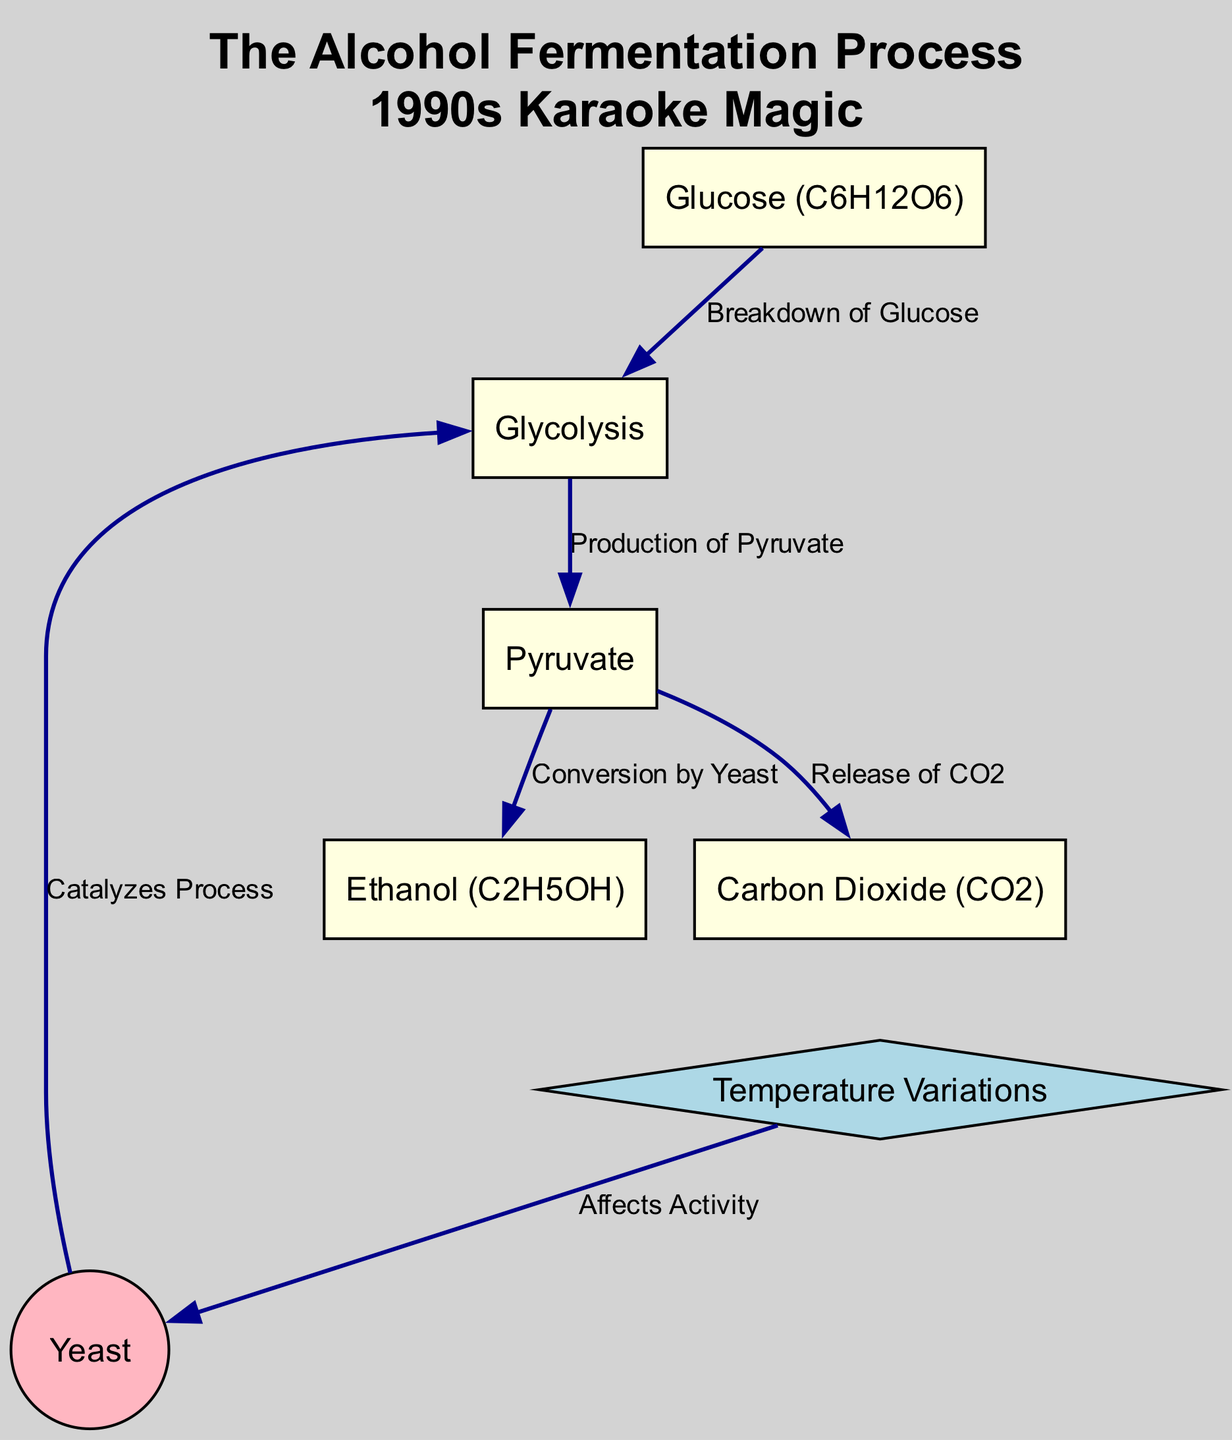What is the initial substance that undergoes fermentation? The diagram indicates that glucose is the starting compound for the fermentation process, as it is the first node before any transformations occur.
Answer: Glucose (C6H12O6) What gas is produced during the fermentation process? According to the diagram, one of the outputs of the fermentation process is carbon dioxide, which is listed directly as a product from pyruvate.
Answer: Carbon Dioxide (CO2) How many main processes are involved after glycolysis? By reviewing the edges connected to the pyruvate node, we see that it branches into two processes: conversion to ethanol and release of CO2, making it a total of two processes after glycolysis.
Answer: Two What role does yeast play in the fermentation process? The diagram shows that yeast is involved in catalyzing the conversion of pyruvate into ethanol, indicating its essential role in the conversion process.
Answer: Catalyzes Process How does temperature affect the alcohol fermentation process? The diagram states that temperature variations impact yeast, thereby affecting its activity, which is crucial for the fermentation efficiency and byproducts.
Answer: Affects Activity What is the output of the conversion of pyruvate by yeast? The diagram specifies that the conversion of pyruvate by yeast leads to the production of ethanol, thus this is the direct result of yeast activity.
Answer: Ethanol (C2H5OH) Which node is represented as a circle? The only node that is styled as a circle, indicating its unique role in the diagram, is yeast, which highlights its distinction among other compounds involved in the process.
Answer: Yeast Can you list the components involved before reaching ethanol? Following the flow from glucose to ethanol, we must consider glucose, glycolysis, and pyruvate, highlighting the direct path of transformation before the final product is created.
Answer: Glucose, Glycolysis, Pyruvate 